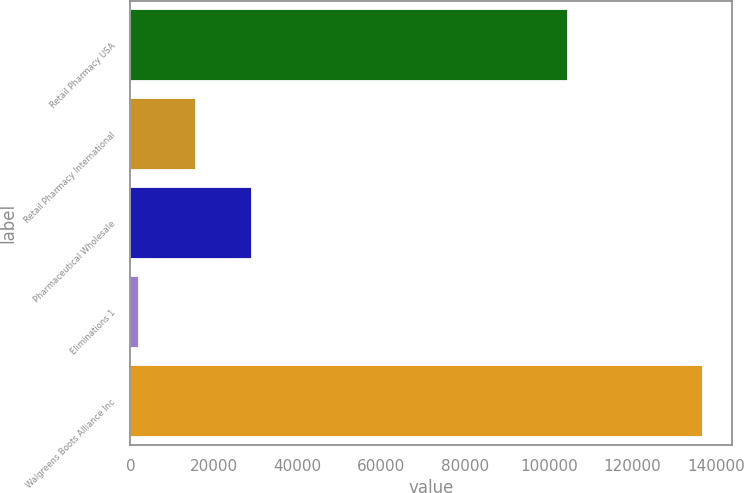<chart> <loc_0><loc_0><loc_500><loc_500><bar_chart><fcel>Retail Pharmacy USA<fcel>Retail Pharmacy International<fcel>Pharmaceutical Wholesale<fcel>Eliminations 1<fcel>Walgreens Boots Alliance Inc<nl><fcel>104532<fcel>15648.6<fcel>29117.2<fcel>2180<fcel>136866<nl></chart> 